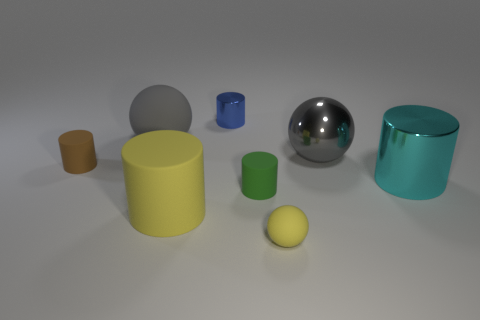Subtract all green cylinders. How many gray spheres are left? 2 Subtract all small yellow balls. How many balls are left? 2 Add 2 cyan cylinders. How many objects exist? 10 Subtract all blue cylinders. How many cylinders are left? 4 Subtract 1 cylinders. How many cylinders are left? 4 Subtract all balls. How many objects are left? 5 Subtract all large rubber balls. Subtract all gray rubber spheres. How many objects are left? 6 Add 4 small matte cylinders. How many small matte cylinders are left? 6 Add 5 small spheres. How many small spheres exist? 6 Subtract 1 blue cylinders. How many objects are left? 7 